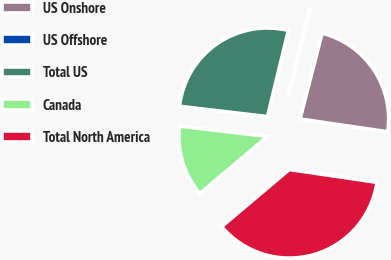Convert chart to OTSL. <chart><loc_0><loc_0><loc_500><loc_500><pie_chart><fcel>US Onshore<fcel>US Offshore<fcel>Total US<fcel>Canada<fcel>Total North America<nl><fcel>23.3%<fcel>0.22%<fcel>26.93%<fcel>13.01%<fcel>36.53%<nl></chart> 